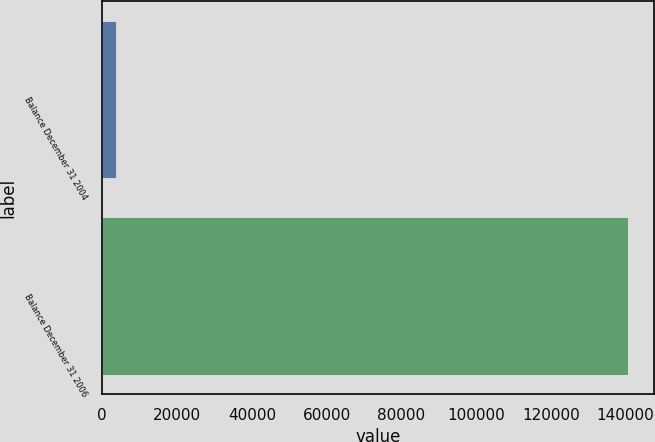Convert chart to OTSL. <chart><loc_0><loc_0><loc_500><loc_500><bar_chart><fcel>Balance December 31 2004<fcel>Balance December 31 2006<nl><fcel>3749<fcel>140509<nl></chart> 